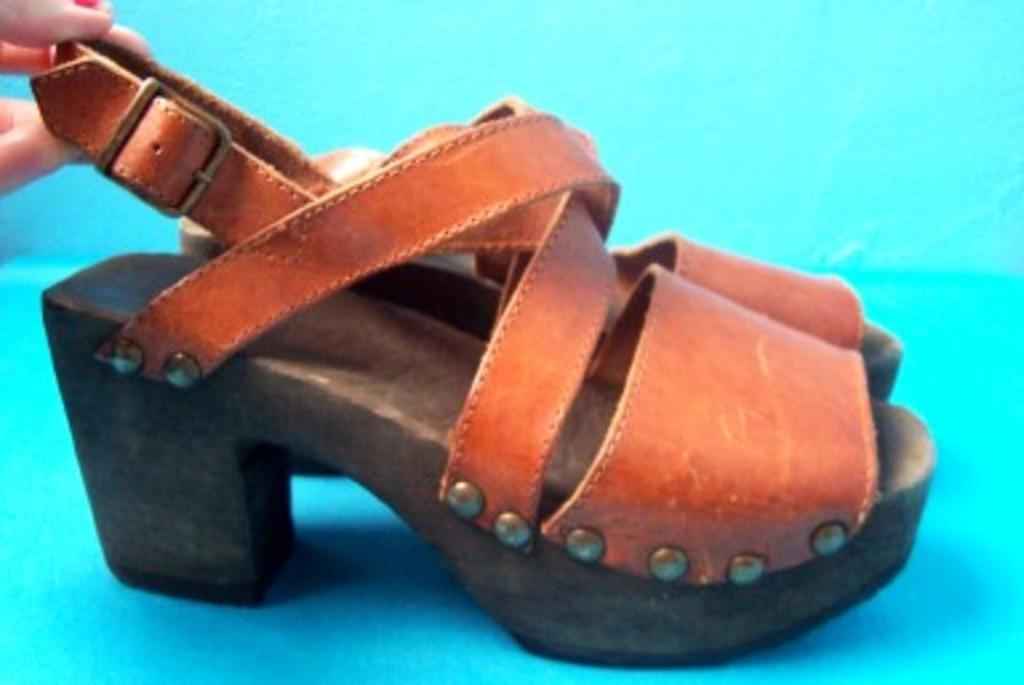What color is the surface visible in the image? The surface in the image is blue. What is placed on the blue surface? There is brown footwear on the blue surface. Can you describe anything else in the image? There is a person's hand in the top left corner of the image. What type of crate is being shaken by the person in the image? There is no crate present in the image, and the person's hand is not shaking anything. 